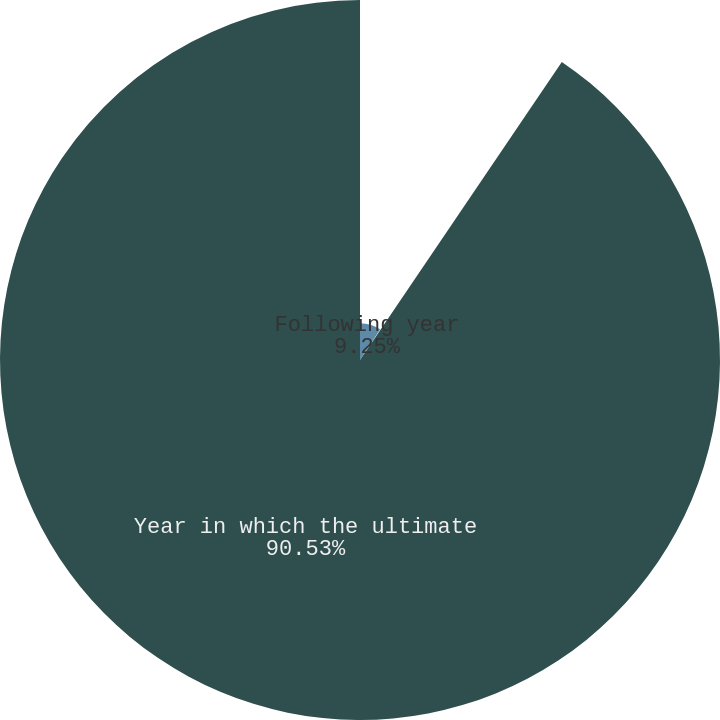Convert chart. <chart><loc_0><loc_0><loc_500><loc_500><pie_chart><fcel>Following year<fcel>Ultimate rate to which cost<fcel>Year in which the ultimate<nl><fcel>9.25%<fcel>0.22%<fcel>90.52%<nl></chart> 